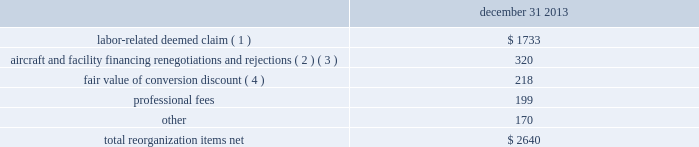Table of contents notes to consolidated financial statements of american airlines , inc .
Certificate of incorporation ( the certificate of incorporation ) contains transfer restrictions applicable to certain substantial stockholders .
Although the purpose of these transfer restrictions is to prevent an ownership change from occurring , there can be no assurance that an ownership change will not occur even with these transfer restrictions .
A copy of the certificate of incorporation was attached as exhibit 3.1 to a current report on form 8-k filed by aag with the sec on december 9 , 2013 .
Reorganization items , net reorganization items refer to revenues , expenses ( including professional fees ) , realized gains and losses and provisions for losses that are realized or incurred in the chapter 11 cases .
The table summarizes the components included in reorganization items , net on the consolidated statement of operations for the year ended december 31 , 2013 ( in millions ) : december 31 .
( 1 ) in exchange for employees 2019 contributions to the successful reorganization , including agreeing to reductions in pay and benefits , american agreed in the plan to provide each employee group a deemed claim , which was used to provide a distribution of a portion of the equity of the reorganized entity to those employees .
Each employee group received a deemed claim amount based upon a portion of the value of cost savings provided by that group through reductions to pay and benefits as well as through certain work rule changes .
The total value of this deemed claim was approximately $ 1.7 billion .
( 2 ) amounts include allowed claims ( claims approved by the bankruptcy court ) and estimated allowed claims relating to ( i ) the rejection or modification of financings related to aircraft and ( ii ) entry of orders treated as unsecured claims with respect to facility agreements supporting certain issuances of special facility revenue bonds .
The debtors recorded an estimated claim associated with the rejection or modification of a financing or facility agreement when the applicable motion was filed with the bankruptcy court to reject or modify such financing or facility agreement and the debtors believed that it was probable the motion would be approved , and there was sufficient information to estimate the claim .
( 3 ) pursuant to the plan , the debtors agreed to allow certain post-petition unsecured claims on obligations .
As a result , during the year ended december 31 , 2013 , american recorded reorganization charges to adjust estimated allowed claim amounts previously recorded on rejected special facility revenue bonds of $ 180 million , allowed general unsecured claims related to the 1990 and 1994 series of special facility revenue bonds that financed certain improvements at john f .
Kennedy international airport ( jfk ) , and rejected bonds that financed certain improvements at chicago o 2019hare international airport ( ord ) , which are included in the table above .
( 4 ) the plan allowed unsecured creditors receiving aag series a preferred stock a conversion discount of 3.5% ( 3.5 % ) .
Accordingly , american recorded the fair value of such discount upon the confirmation of the plan by the bankruptcy court. .
What is the ratio of the labor-related deemed claim to the other fees? 
Rationale: there is $ 10.2 of labor-related deemed claim for every $ 1 of other fees
Computations: (1733 / 170)
Answer: 10.19412. Table of contents notes to consolidated financial statements of american airlines , inc .
Certificate of incorporation ( the certificate of incorporation ) contains transfer restrictions applicable to certain substantial stockholders .
Although the purpose of these transfer restrictions is to prevent an ownership change from occurring , there can be no assurance that an ownership change will not occur even with these transfer restrictions .
A copy of the certificate of incorporation was attached as exhibit 3.1 to a current report on form 8-k filed by aag with the sec on december 9 , 2013 .
Reorganization items , net reorganization items refer to revenues , expenses ( including professional fees ) , realized gains and losses and provisions for losses that are realized or incurred in the chapter 11 cases .
The table summarizes the components included in reorganization items , net on the consolidated statement of operations for the year ended december 31 , 2013 ( in millions ) : december 31 .
( 1 ) in exchange for employees 2019 contributions to the successful reorganization , including agreeing to reductions in pay and benefits , american agreed in the plan to provide each employee group a deemed claim , which was used to provide a distribution of a portion of the equity of the reorganized entity to those employees .
Each employee group received a deemed claim amount based upon a portion of the value of cost savings provided by that group through reductions to pay and benefits as well as through certain work rule changes .
The total value of this deemed claim was approximately $ 1.7 billion .
( 2 ) amounts include allowed claims ( claims approved by the bankruptcy court ) and estimated allowed claims relating to ( i ) the rejection or modification of financings related to aircraft and ( ii ) entry of orders treated as unsecured claims with respect to facility agreements supporting certain issuances of special facility revenue bonds .
The debtors recorded an estimated claim associated with the rejection or modification of a financing or facility agreement when the applicable motion was filed with the bankruptcy court to reject or modify such financing or facility agreement and the debtors believed that it was probable the motion would be approved , and there was sufficient information to estimate the claim .
( 3 ) pursuant to the plan , the debtors agreed to allow certain post-petition unsecured claims on obligations .
As a result , during the year ended december 31 , 2013 , american recorded reorganization charges to adjust estimated allowed claim amounts previously recorded on rejected special facility revenue bonds of $ 180 million , allowed general unsecured claims related to the 1990 and 1994 series of special facility revenue bonds that financed certain improvements at john f .
Kennedy international airport ( jfk ) , and rejected bonds that financed certain improvements at chicago o 2019hare international airport ( ord ) , which are included in the table above .
( 4 ) the plan allowed unsecured creditors receiving aag series a preferred stock a conversion discount of 3.5% ( 3.5 % ) .
Accordingly , american recorded the fair value of such discount upon the confirmation of the plan by the bankruptcy court. .
What portion of the total net reorganization items are related to labor deemed claim? 
Computations: (1733 / 2640)
Answer: 0.65644. 